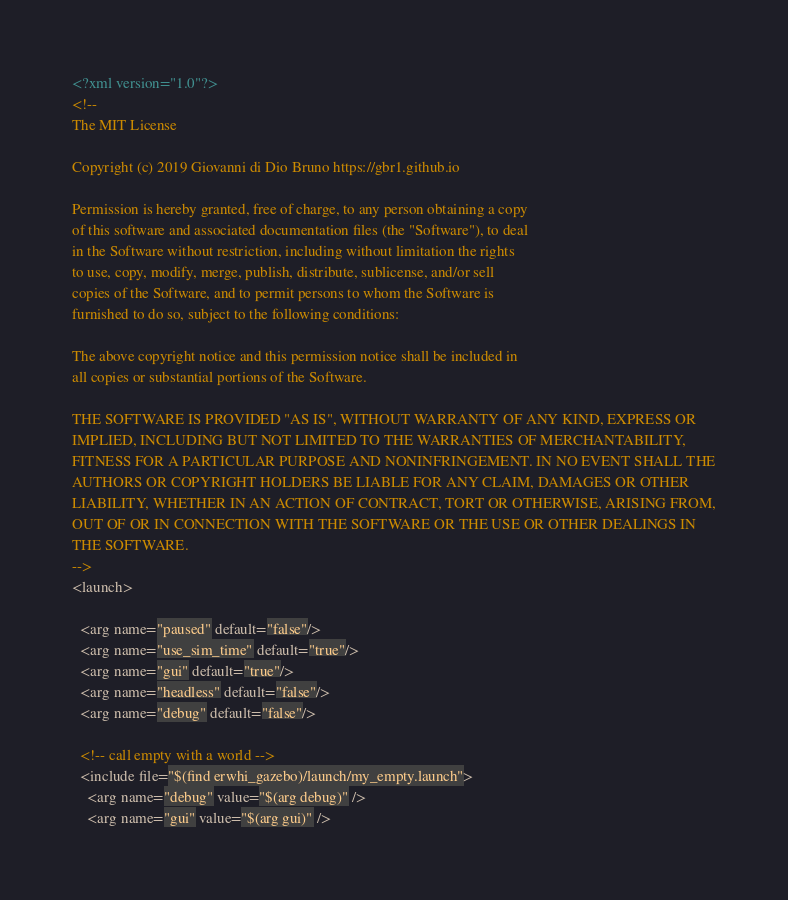<code> <loc_0><loc_0><loc_500><loc_500><_XML_><?xml version="1.0"?>
<!--
The MIT License

Copyright (c) 2019 Giovanni di Dio Bruno https://gbr1.github.io

Permission is hereby granted, free of charge, to any person obtaining a copy
of this software and associated documentation files (the "Software"), to deal
in the Software without restriction, including without limitation the rights
to use, copy, modify, merge, publish, distribute, sublicense, and/or sell
copies of the Software, and to permit persons to whom the Software is
furnished to do so, subject to the following conditions:

The above copyright notice and this permission notice shall be included in
all copies or substantial portions of the Software.

THE SOFTWARE IS PROVIDED "AS IS", WITHOUT WARRANTY OF ANY KIND, EXPRESS OR
IMPLIED, INCLUDING BUT NOT LIMITED TO THE WARRANTIES OF MERCHANTABILITY,
FITNESS FOR A PARTICULAR PURPOSE AND NONINFRINGEMENT. IN NO EVENT SHALL THE
AUTHORS OR COPYRIGHT HOLDERS BE LIABLE FOR ANY CLAIM, DAMAGES OR OTHER
LIABILITY, WHETHER IN AN ACTION OF CONTRACT, TORT OR OTHERWISE, ARISING FROM,
OUT OF OR IN CONNECTION WITH THE SOFTWARE OR THE USE OR OTHER DEALINGS IN
THE SOFTWARE.
-->
<launch>

  <arg name="paused" default="false"/>
  <arg name="use_sim_time" default="true"/>
  <arg name="gui" default="true"/>
  <arg name="headless" default="false"/>
  <arg name="debug" default="false"/>

  <!-- call empty with a world -->
  <include file="$(find erwhi_gazebo)/launch/my_empty.launch">
    <arg name="debug" value="$(arg debug)" />
    <arg name="gui" value="$(arg gui)" /></code> 